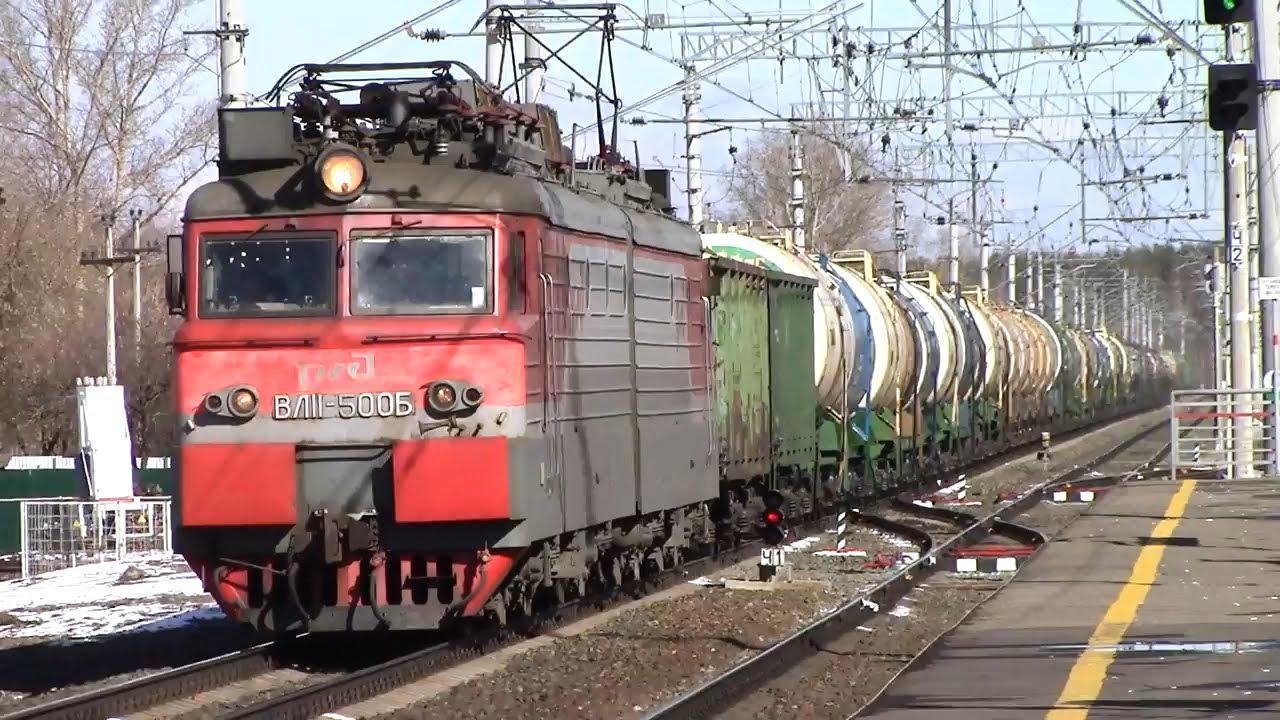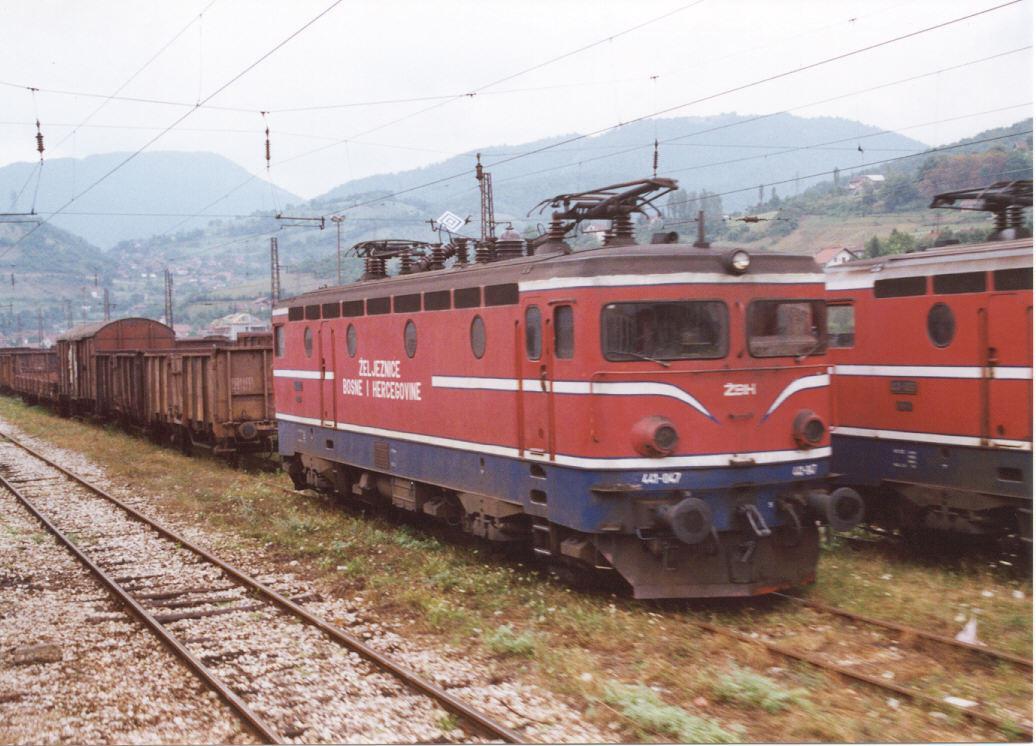The first image is the image on the left, the second image is the image on the right. Assess this claim about the two images: "There is a white stripe all the way around the bottom of the train in the image on the right.". Correct or not? Answer yes or no. Yes. 